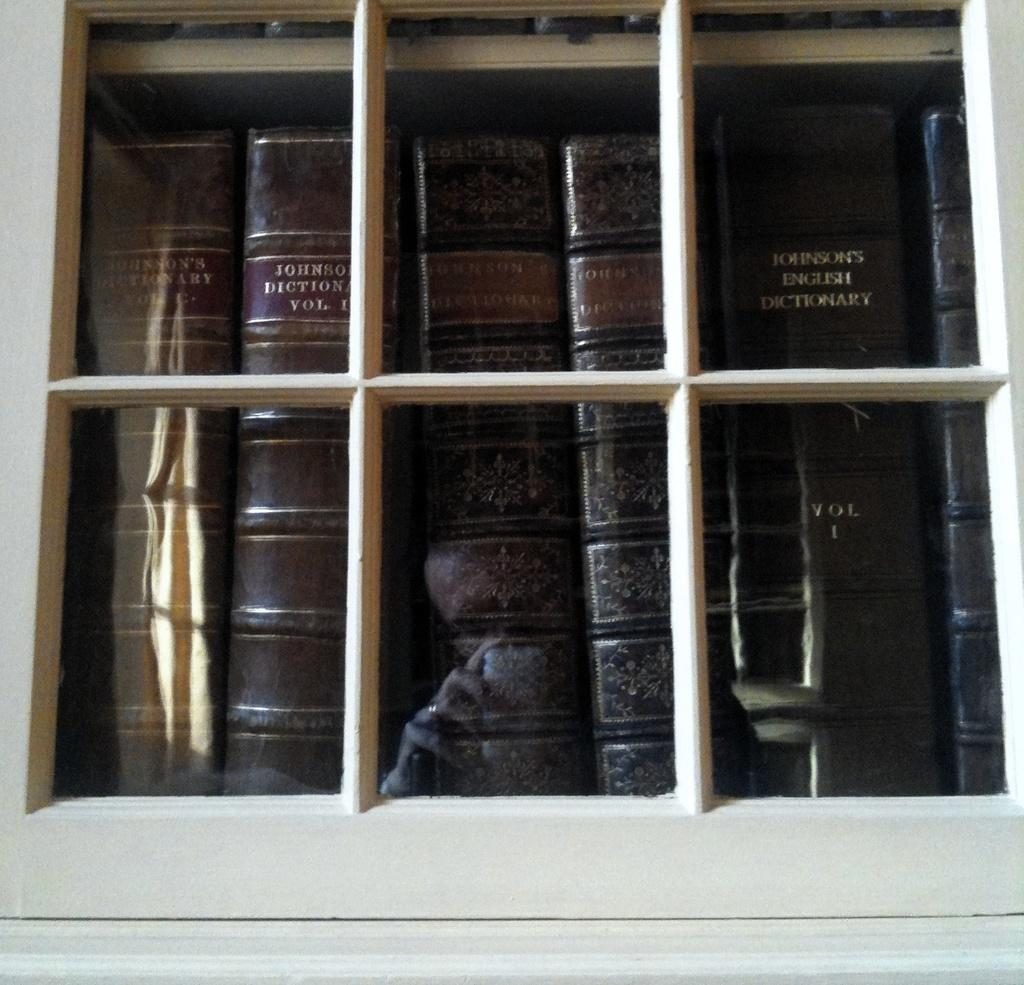<image>
Give a short and clear explanation of the subsequent image. Brown books behind a window including one that says Vol 1. 